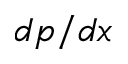<formula> <loc_0><loc_0><loc_500><loc_500>d p / d x</formula> 